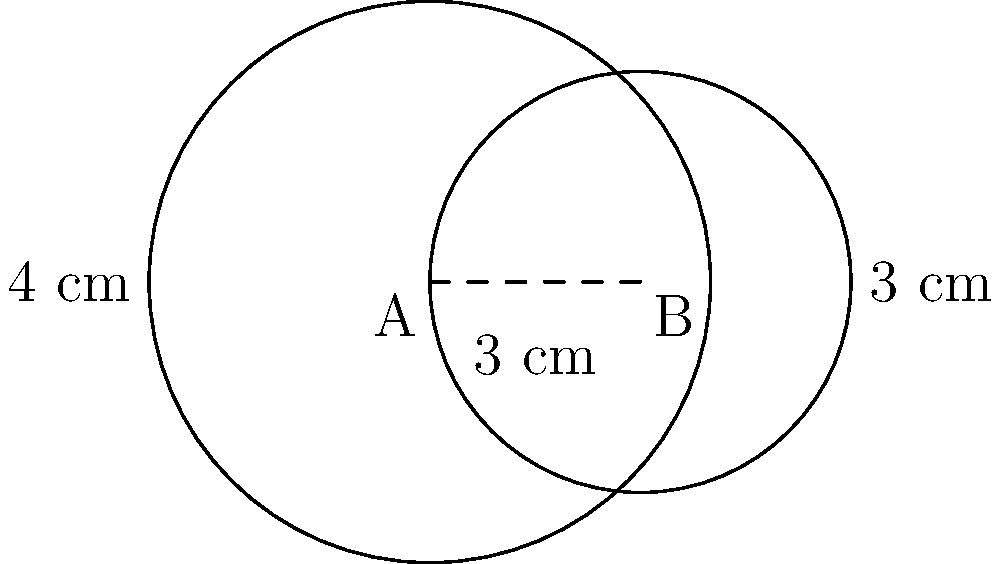In a virology experiment, two circular cell cultures A and B are grown on a plate. Culture A has a radius of 4 cm, while culture B has a radius of 3 cm. The centers of these cultures are 3 cm apart. Calculate the area of the overlapping region between the two cultures. Round your answer to two decimal places. To solve this problem, we'll use the formula for the area of intersection between two circles. Let's approach this step-by-step:

1) First, we need to calculate the distance between the centers (d) and the radii (r1 and r2):
   d = 3 cm
   r1 = 4 cm (Culture A)
   r2 = 3 cm (Culture B)

2) Now, we'll use the formula for the area of intersection:

   $$A = r_1^2 \arccos(\frac{d^2 + r_1^2 - r_2^2}{2dr_1}) + r_2^2 \arccos(\frac{d^2 + r_2^2 - r_1^2}{2dr_2}) - \frac{1}{2}\sqrt{(-d+r_1+r_2)(d+r_1-r_2)(d-r_1+r_2)(d+r_1+r_2)}$$

3) Let's calculate each part:

   Part 1: $$r_1^2 \arccos(\frac{d^2 + r_1^2 - r_2^2}{2dr_1}) = 16 \arccos(\frac{3^2 + 4^2 - 3^2}{2 \cdot 3 \cdot 4}) = 16 \arccos(\frac{13}{24})$$

   Part 2: $$r_2^2 \arccos(\frac{d^2 + r_2^2 - r_1^2}{2dr_2}) = 9 \arccos(\frac{3^2 + 3^2 - 4^2}{2 \cdot 3 \cdot 3}) = 9 \arccos(\frac{2}{9})$$

   Part 3: $$\frac{1}{2}\sqrt{(-d+r_1+r_2)(d+r_1-r_2)(d-r_1+r_2)(d+r_1+r_2)} = \frac{1}{2}\sqrt{(4)(4)(0)(10)} = 0$$

4) Adding these parts:

   $$A = 16 \arccos(\frac{13}{24}) + 9 \arccos(\frac{2}{9}) - 0$$

5) Using a calculator and rounding to two decimal places:

   A ≈ 12.37 cm²
Answer: 12.37 cm² 